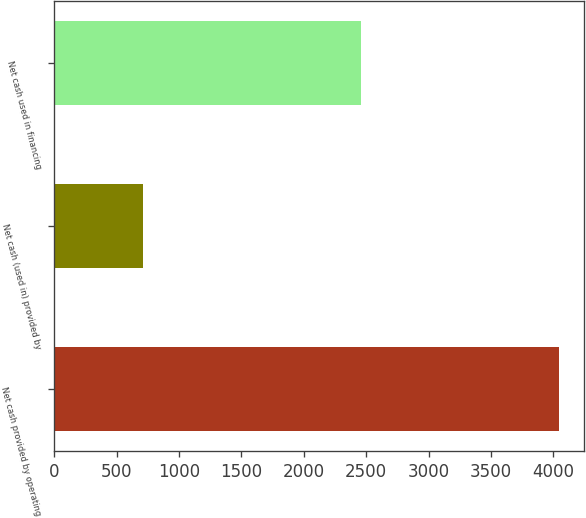<chart> <loc_0><loc_0><loc_500><loc_500><bar_chart><fcel>Net cash provided by operating<fcel>Net cash (used in) provided by<fcel>Net cash used in financing<nl><fcel>4043<fcel>715<fcel>2458<nl></chart> 